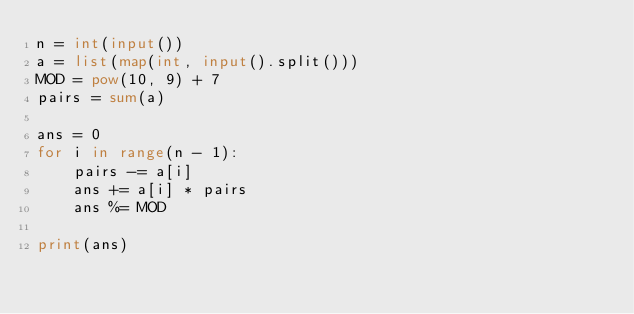<code> <loc_0><loc_0><loc_500><loc_500><_Python_>n = int(input())
a = list(map(int, input().split()))
MOD = pow(10, 9) + 7
pairs = sum(a)

ans = 0
for i in range(n - 1):
    pairs -= a[i]
    ans += a[i] * pairs
    ans %= MOD

print(ans)
</code> 